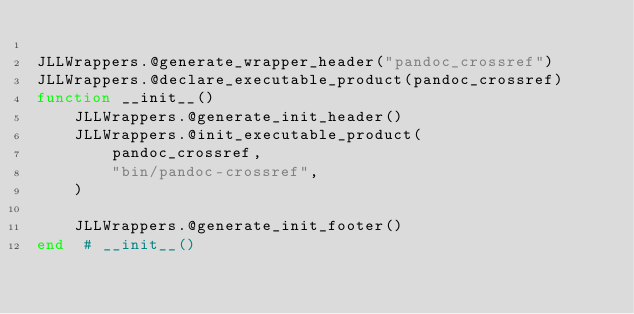<code> <loc_0><loc_0><loc_500><loc_500><_Julia_>
JLLWrappers.@generate_wrapper_header("pandoc_crossref")
JLLWrappers.@declare_executable_product(pandoc_crossref)
function __init__()
    JLLWrappers.@generate_init_header()
    JLLWrappers.@init_executable_product(
        pandoc_crossref,
        "bin/pandoc-crossref",
    )

    JLLWrappers.@generate_init_footer()
end  # __init__()
</code> 